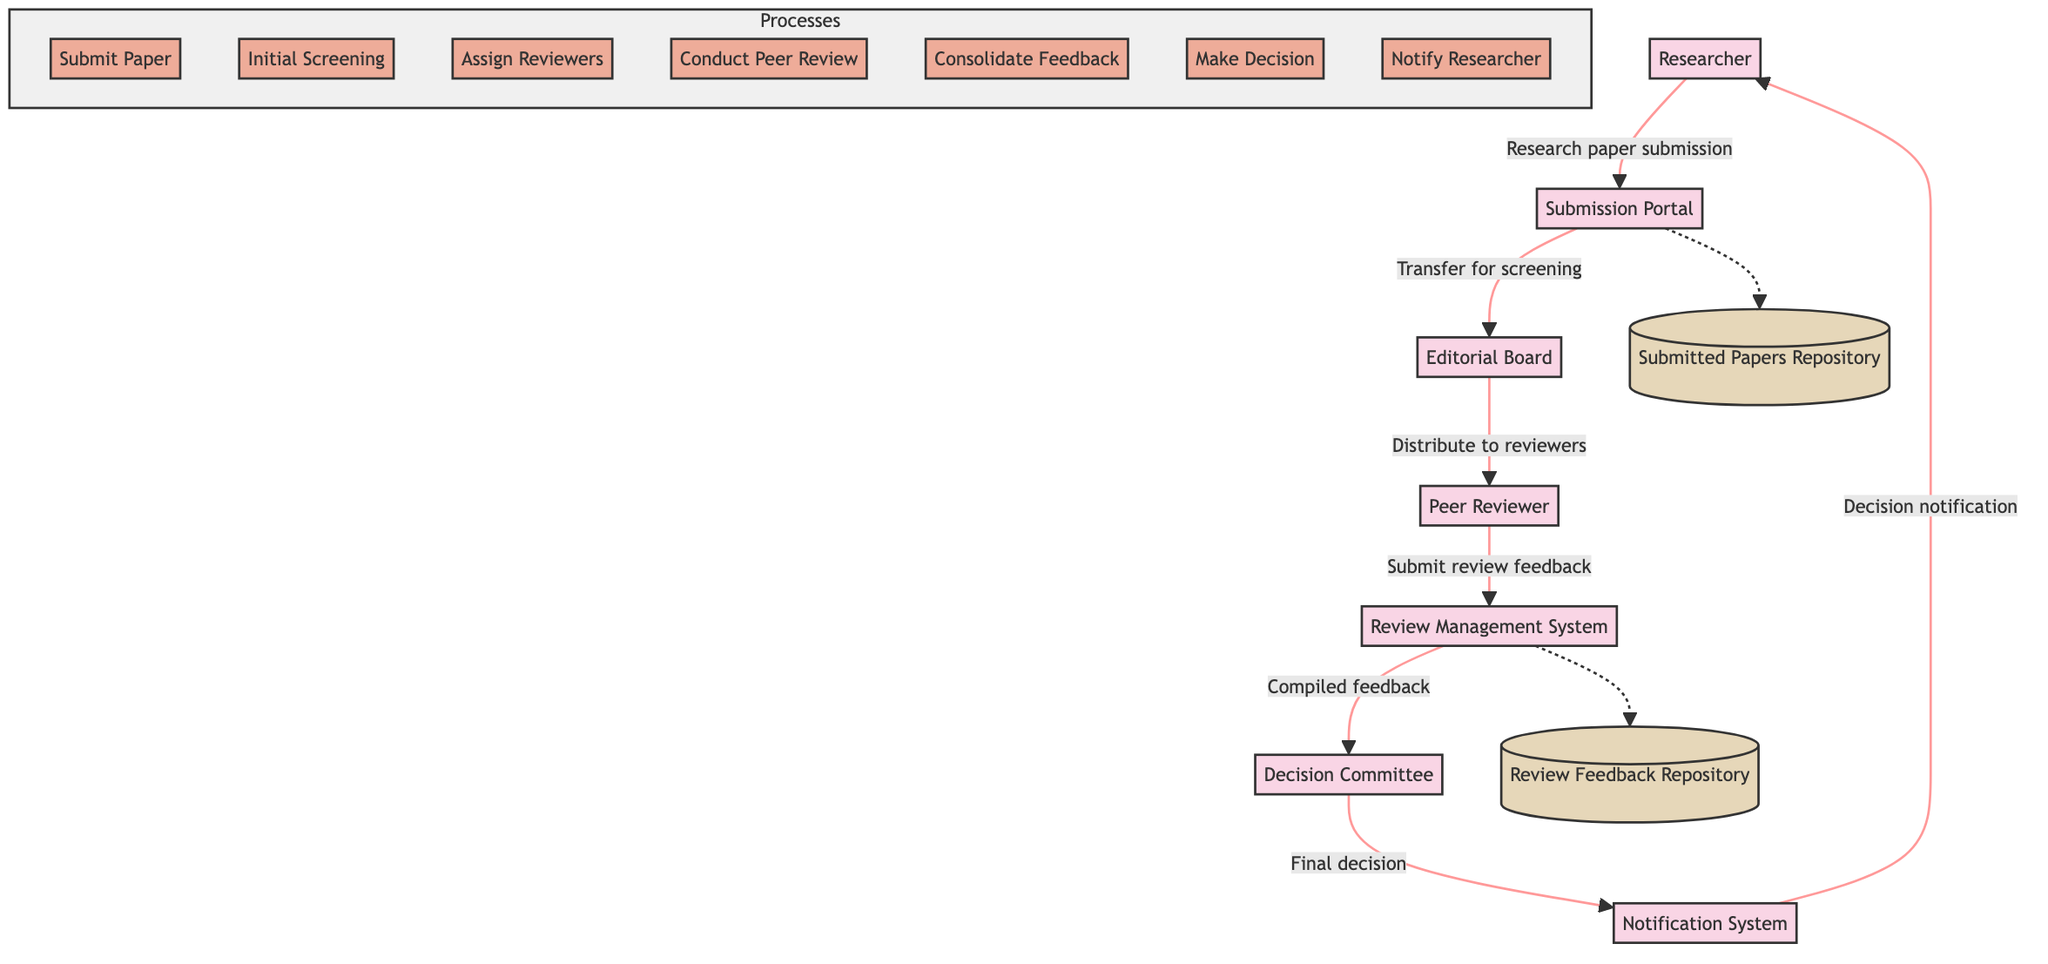What is the role of the Peer Reviewer? The Peer Reviewer is an expert who assesses the quality and accuracy of the research paper.
Answer: Expert assessment How many data stores are present in the diagram? The diagram contains two data stores, which are the Submitted Papers Repository and the Review Feedback Repository.
Answer: Two What is the first action taken after the researcher submits the paper? The first action taken is the Submission Portal transferring the submitted paper to the Editorial Board for initial screening.
Answer: Transfer for screening Which system compiles the feedback received from reviewers? The Review Management System compiles the feedback received from peer reviewers.
Answer: Review Management System Which entity notifies the researcher about the final decision? The Notification System is responsible for notifying the researcher about the final decision and feedback.
Answer: Notification System How many processes are involved in the workflow? There are seven processes involved in the workflow which include Submit Paper, Initial Screening, Assign Reviewers, Conduct Peer Review, Consolidate Feedback, Make Decision, and Notify Researcher.
Answer: Seven What happens after the Editorial Board completes the initial screening? After the initial screening, the Editorial Board assigns peer reviewers based on their expertise to assess the research paper.
Answer: Assign reviewers From which entity does the Decision Committee receive compiled feedback? The Decision Committee receives the compiled feedback from the Review Management System, which aggregates all reviewer assessments.
Answer: Review Management System How does the research paper reach the Editorial Board? The research paper reaches the Editorial Board through the submission made by the researcher via the Submission Portal.
Answer: Submission Portal 